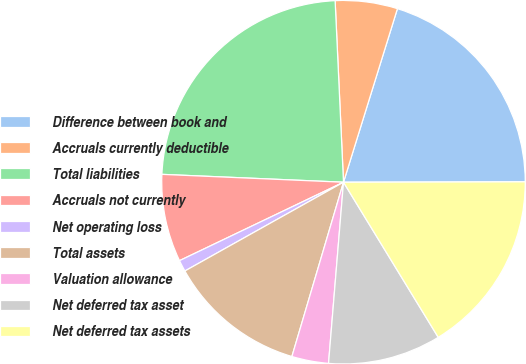Convert chart. <chart><loc_0><loc_0><loc_500><loc_500><pie_chart><fcel>Difference between book and<fcel>Accruals currently deductible<fcel>Total liabilities<fcel>Accruals not currently<fcel>Net operating loss<fcel>Total assets<fcel>Valuation allowance<fcel>Net deferred tax asset<fcel>Net deferred tax assets<nl><fcel>20.17%<fcel>5.53%<fcel>23.58%<fcel>7.79%<fcel>1.02%<fcel>12.3%<fcel>3.27%<fcel>10.04%<fcel>16.31%<nl></chart> 